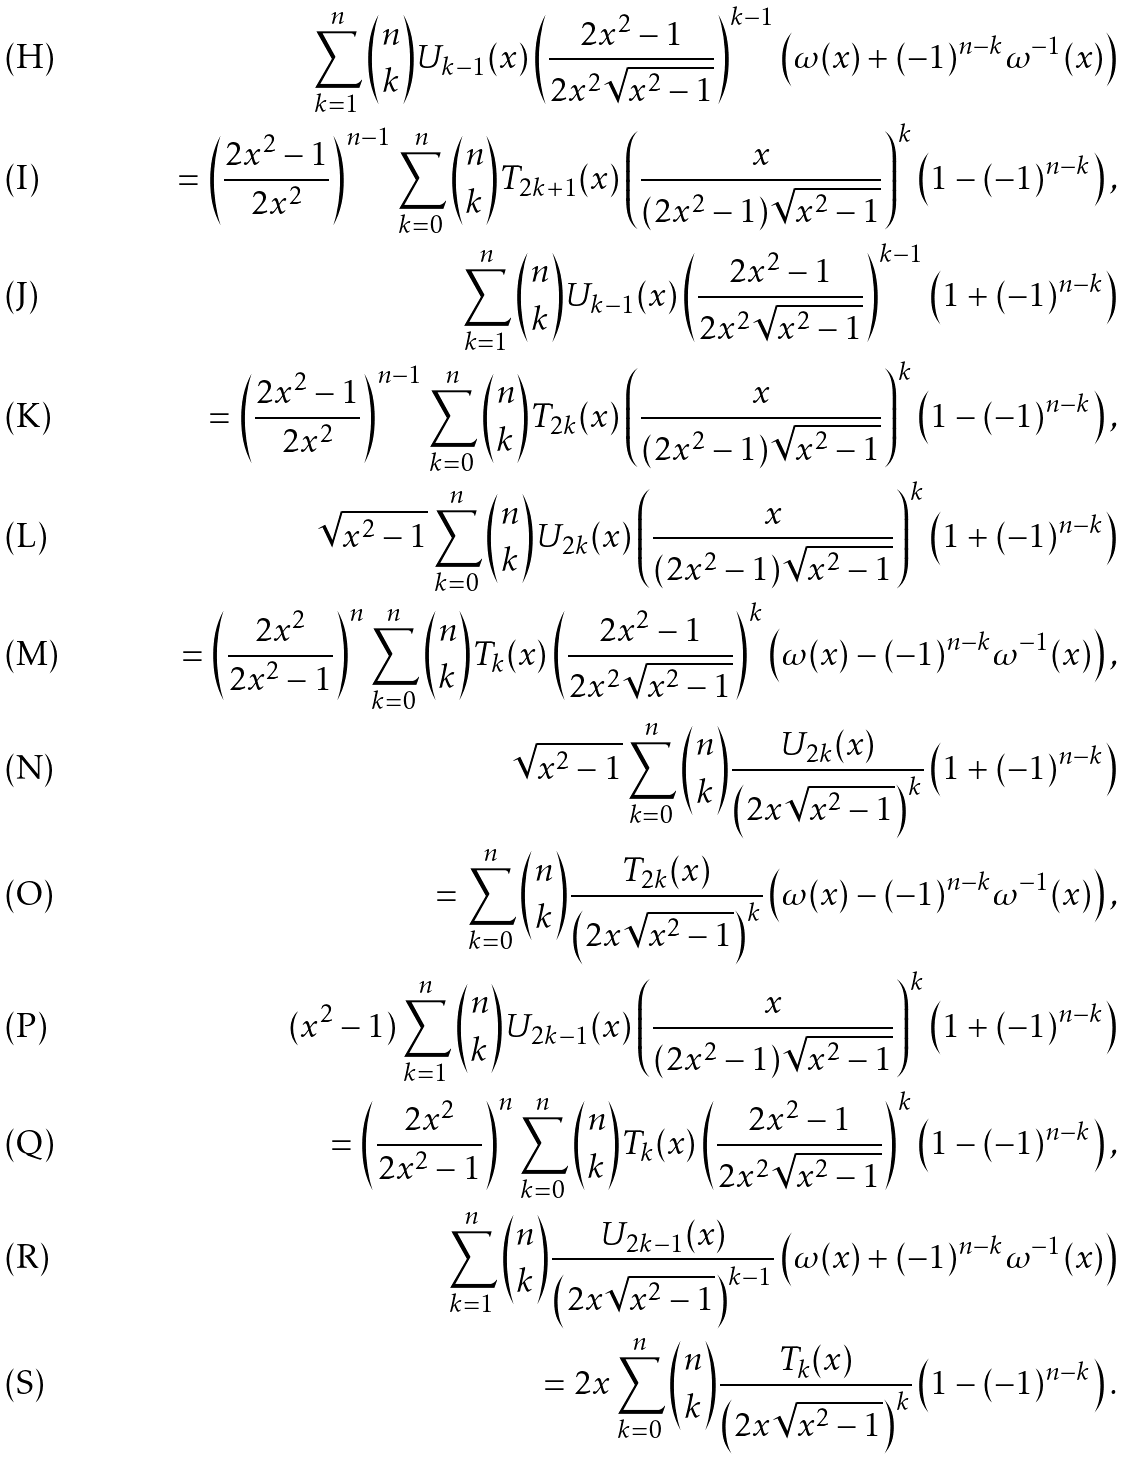Convert formula to latex. <formula><loc_0><loc_0><loc_500><loc_500>\sum _ { k = 1 } ^ { n } { n \choose k } U _ { k - 1 } ( x ) \left ( \frac { 2 x ^ { 2 } - 1 } { 2 x ^ { 2 } \sqrt { x ^ { 2 } - 1 } } \right ) ^ { k - 1 } \left ( \omega ( x ) + ( - 1 ) ^ { n - k } \omega ^ { - 1 } ( x ) \right ) \\ = \left ( \frac { 2 x ^ { 2 } - 1 } { 2 x ^ { 2 } } \right ) ^ { n - 1 } \sum _ { k = 0 } ^ { n } { n \choose k } T _ { 2 k + 1 } ( x ) \left ( \frac { x } { ( 2 x ^ { 2 } - 1 ) \sqrt { x ^ { 2 } - 1 } } \right ) ^ { k } \left ( 1 - ( - 1 ) ^ { n - k } \right ) , \\ \sum _ { k = 1 } ^ { n } { n \choose k } U _ { k - 1 } ( x ) \left ( \frac { 2 x ^ { 2 } - 1 } { 2 x ^ { 2 } \sqrt { x ^ { 2 } - 1 } } \right ) ^ { k - 1 } \left ( 1 + ( - 1 ) ^ { n - k } \right ) \\ = \left ( \frac { 2 x ^ { 2 } - 1 } { 2 x ^ { 2 } } \right ) ^ { n - 1 } \sum _ { k = 0 } ^ { n } { n \choose k } T _ { 2 k } ( x ) \left ( \frac { x } { ( 2 x ^ { 2 } - 1 ) \sqrt { x ^ { 2 } - 1 } } \right ) ^ { k } \left ( 1 - ( - 1 ) ^ { n - k } \right ) , \\ \sqrt { x ^ { 2 } - 1 } \sum _ { k = 0 } ^ { n } { n \choose k } U _ { 2 k } ( x ) \left ( \frac { x } { ( 2 x ^ { 2 } - 1 ) \sqrt { x ^ { 2 } - 1 } } \right ) ^ { k } \left ( 1 + ( - 1 ) ^ { n - k } \right ) \\ = \left ( \frac { 2 x ^ { 2 } } { 2 x ^ { 2 } - 1 } \right ) ^ { n } \sum _ { k = 0 } ^ { n } { n \choose k } T _ { k } ( x ) \left ( \frac { 2 x ^ { 2 } - 1 } { 2 x ^ { 2 } \sqrt { x ^ { 2 } - 1 } } \right ) ^ { k } \left ( \omega ( x ) - ( - 1 ) ^ { n - k } \omega ^ { - 1 } ( x ) \right ) , \\ \sqrt { x ^ { 2 } - 1 } \sum _ { k = 0 } ^ { n } { n \choose k } \frac { U _ { 2 k } ( x ) } { \left ( 2 x \sqrt { x ^ { 2 } - 1 } \right ) ^ { k } } \left ( 1 + ( - 1 ) ^ { n - k } \right ) \\ = \sum _ { k = 0 } ^ { n } { n \choose k } \frac { T _ { 2 k } ( x ) } { \left ( 2 x \sqrt { x ^ { 2 } - 1 } \right ) ^ { k } } \left ( \omega ( x ) - ( - 1 ) ^ { n - k } \omega ^ { - 1 } ( x ) \right ) , \\ ( x ^ { 2 } - 1 ) \sum _ { k = 1 } ^ { n } { n \choose k } U _ { 2 k - 1 } ( x ) \left ( \frac { x } { ( 2 x ^ { 2 } - 1 ) \sqrt { x ^ { 2 } - 1 } } \right ) ^ { k } \left ( 1 + ( - 1 ) ^ { n - k } \right ) \\ = \left ( \frac { 2 x ^ { 2 } } { 2 x ^ { 2 } - 1 } \right ) ^ { n } \sum _ { k = 0 } ^ { n } { n \choose k } T _ { k } ( x ) \left ( \frac { 2 x ^ { 2 } - 1 } { 2 x ^ { 2 } \sqrt { x ^ { 2 } - 1 } } \right ) ^ { k } \left ( 1 - ( - 1 ) ^ { n - k } \right ) , \\ \sum _ { k = 1 } ^ { n } { n \choose k } \frac { U _ { 2 k - 1 } ( x ) } { \left ( 2 x \sqrt { x ^ { 2 } - 1 } \right ) ^ { k - 1 } } \left ( \omega ( x ) + ( - 1 ) ^ { n - k } \omega ^ { - 1 } ( x ) \right ) \\ = 2 x \sum _ { k = 0 } ^ { n } { n \choose k } \frac { T _ { k } ( x ) } { \left ( 2 x \sqrt { x ^ { 2 } - 1 } \right ) ^ { k } } \left ( 1 - ( - 1 ) ^ { n - k } \right ) .</formula> 